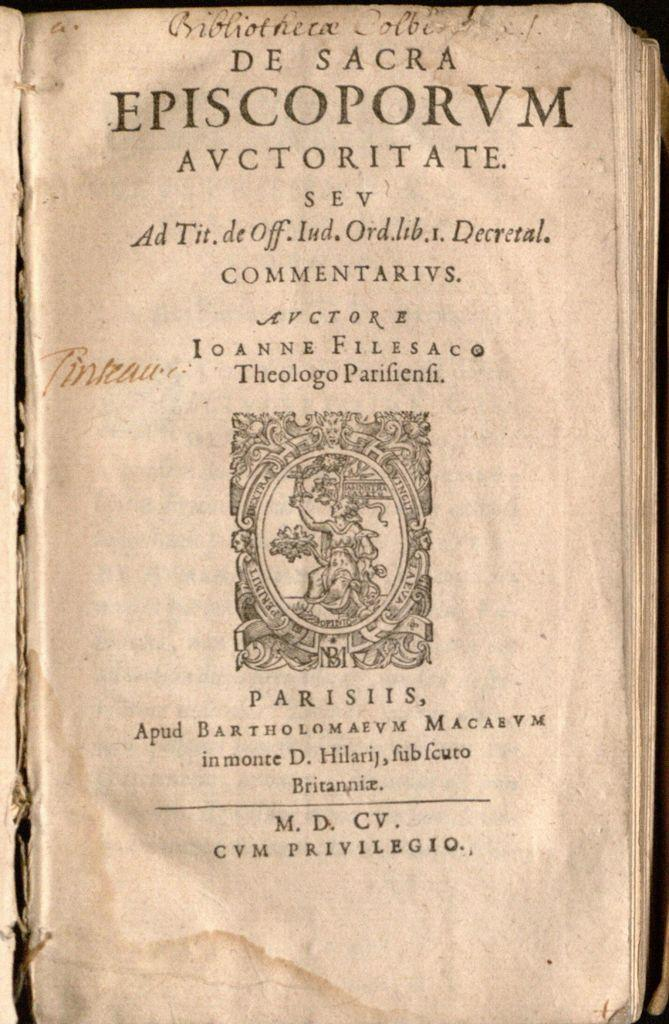<image>
Render a clear and concise summary of the photo. An old text titled De Sacra Episcoporvm Avctoritate. 